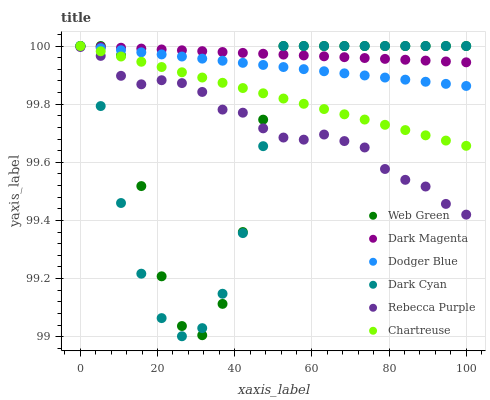Does Dark Cyan have the minimum area under the curve?
Answer yes or no. Yes. Does Dark Magenta have the maximum area under the curve?
Answer yes or no. Yes. Does Web Green have the minimum area under the curve?
Answer yes or no. No. Does Web Green have the maximum area under the curve?
Answer yes or no. No. Is Dark Magenta the smoothest?
Answer yes or no. Yes. Is Web Green the roughest?
Answer yes or no. Yes. Is Chartreuse the smoothest?
Answer yes or no. No. Is Chartreuse the roughest?
Answer yes or no. No. Does Dark Cyan have the lowest value?
Answer yes or no. Yes. Does Web Green have the lowest value?
Answer yes or no. No. Does Dark Cyan have the highest value?
Answer yes or no. Yes. Does Rebecca Purple have the highest value?
Answer yes or no. No. Is Rebecca Purple less than Chartreuse?
Answer yes or no. Yes. Is Dodger Blue greater than Rebecca Purple?
Answer yes or no. Yes. Does Dodger Blue intersect Dark Magenta?
Answer yes or no. Yes. Is Dodger Blue less than Dark Magenta?
Answer yes or no. No. Is Dodger Blue greater than Dark Magenta?
Answer yes or no. No. Does Rebecca Purple intersect Chartreuse?
Answer yes or no. No. 